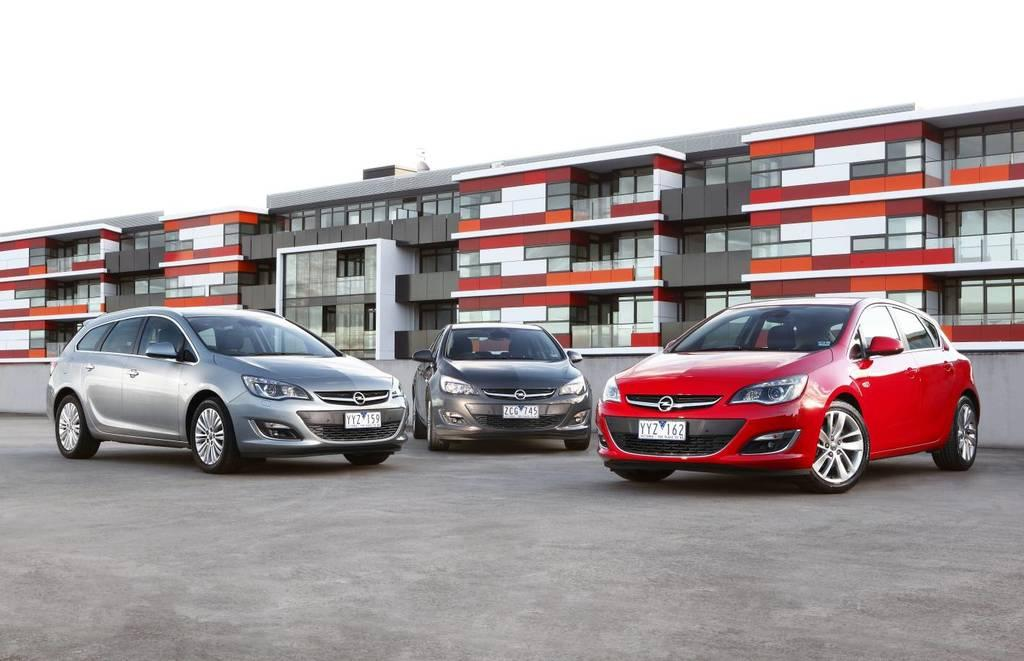What objects are on the floor in the image? There are cars on the floor in the image. What type of structures can be seen in the image? There are buildings visible in the image. What is visible at the top of the image? The sky is visible at the top of the image. What type of education can be seen on the desk in the image? There is no desk present in the image, so it is not possible to answer a question about education on a desk. 